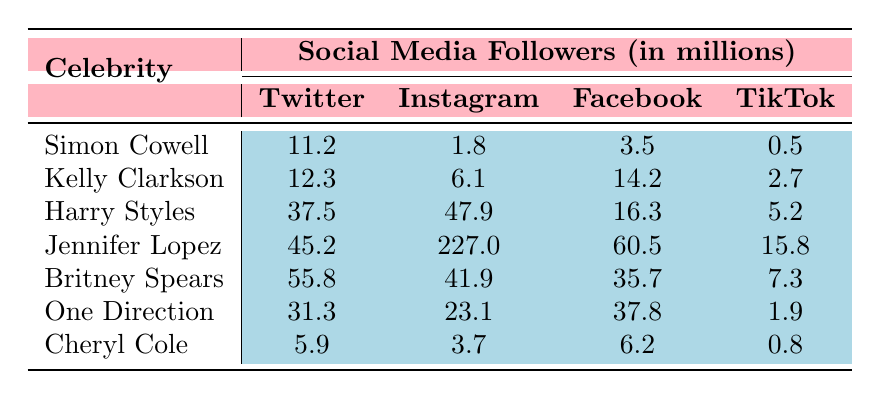What is the follower count of Britney Spears on Instagram? According to the table, Britney Spears has 41.9 million followers on Instagram.
Answer: 41.9 million Who has the highest number of followers on Twitter among the celebrities listed? Looking at the Twitter column, Jennifer Lopez has the highest follower count with 45.2 million.
Answer: Jennifer Lopez If we add the Instagram and Twitter followers of Kelly Clarkson, what total do we get? Kelly Clarkson has 12.3 million Twitter and 6.1 million Instagram followers. Adding these together gives 12.3 + 6.1 = 18.4 million.
Answer: 18.4 million Does Cheryl Cole have more followers on TikTok than Simon Cowell? Cheryl Cole has 0.8 million followers on TikTok while Simon Cowell has 0.5 million. Since 0.8 million is greater than 0.5 million, the answer is yes.
Answer: Yes What is the total number of followers across all platforms for Harry Styles? For Harry Styles, the followers are: Twitter (37.5), Instagram (47.9), Facebook (16.3), and TikTok (5.2). Summing these gives 37.5 + 47.9 + 16.3 + 5.2 = 106.9 million.
Answer: 106.9 million Who has the largest following on Facebook, and how many followers do they have? By checking the Facebook column, Jennifer Lopez has the most followers at 60.5 million.
Answer: Jennifer Lopez, 60.5 million What is the difference in Instagram followers between Britney Spears and One Direction? Britney Spears has 41.9 million while One Direction has 23.1 million on Instagram. The difference is 41.9 - 23.1 = 18.8 million.
Answer: 18.8 million If you combine the TikTok followers of All celebrities, what is the total? The TikTok followers are: Simon Cowell (0.5), Kelly Clarkson (2.7), Harry Styles (5.2), Jennifer Lopez (15.8), Britney Spears (7.3), One Direction (1.9), and Cheryl Cole (0.8). Adding these gives 0.5 + 2.7 + 5.2 + 15.8 + 7.3 + 1.9 + 0.8 = 34.2 million.
Answer: 34.2 million What percentage of Jennifer Lopez's followers on Instagram compared to her total followers across all platforms? Jennifer Lopez has 227 million Instagram followers and her total followers from all platforms are 60.5 + 45.2 + 227 + 15.8 = 348.5 million. The percentage is (227/348.5) * 100 ≈ 65%.
Answer: ~65% Who has the lowest overall presence on social media based on the data provided? Cheryl Cole has the lowest total of 5.9 + 3.7 + 6.2 + 0.8 = 16.6 million across all platforms compared to others.
Answer: Cheryl Cole, 16.6 million 